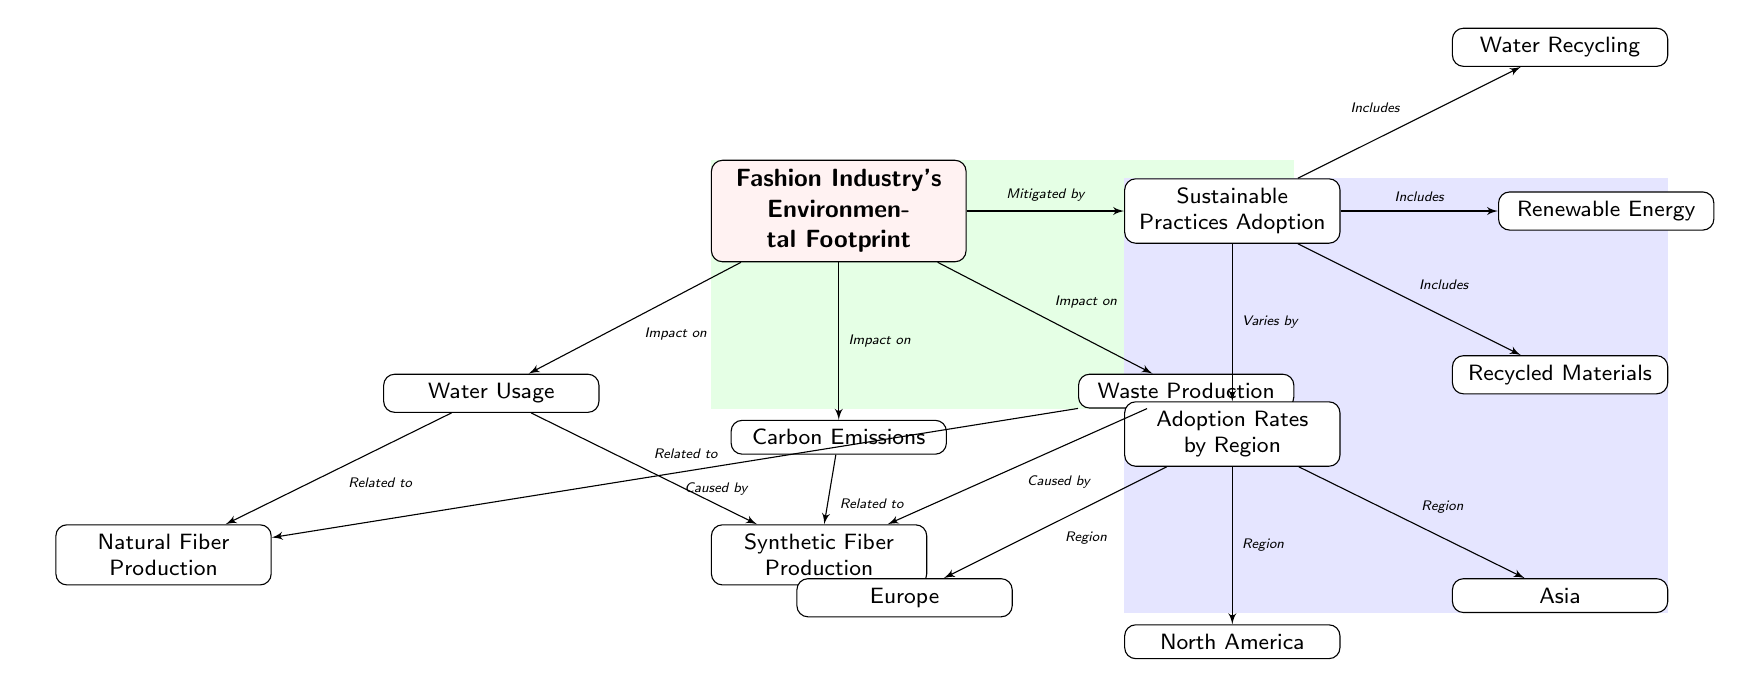What is the main subject of the diagram? The central node labeled "Fashion Industry's Environmental Footprint" indicates that the primary focus of the diagram is to analyze the environmental impact of the fashion industry.
Answer: Fashion Industry's Environmental Footprint How many sustainable practices are mentioned in the diagram? The diagram includes three sustainable practices: Water Recycling, Renewable Energy, and Recycled Materials, which are all listed under the "Sustainable Practices Adoption" node.
Answer: Three What type of relationship connects "Fashion Industry's Environmental Footprint" to "Waste Production"? The connection between these two nodes is labeled "Impact on," showing that the environmental footprint of the fashion industry impacts waste production.
Answer: Impact on Which region is listed as a category for adoption rates? The node directly under "Adoption Rates by Region" is labeled "Europe," indicating that it is one of the regions analyzed for sustainable practice adoption rates.
Answer: Europe What does the edge between "Synthetic Fiber Production" and "Carbon Emissions" imply? The edge labeled "Related to" indicates that there is a relationship where synthetic fiber production contributes or correlates to carbon emissions in the fashion industry.
Answer: Related to What is the relationship between "Water Usage" and "Natural Fiber Production"? The relationship is indicated by the edge labeled "Related to," suggesting that water usage is connected to the production of natural fibers.
Answer: Related to How is the adoption of sustainable practices influenced according to the diagram? The diagram states that the adoption of sustainable practices varies by region, as indicated by the "Varies by" label connecting sustainable practices to the "Adoption Rates by Region" node.
Answer: Varies by Which environment impact causes waste production? The diagram specifies that waste production is caused by both synthetic fiber production and natural fiber production, as indicated by the edges labeled "Caused by."
Answer: Caused by In the diagram, what does the green background represent? The green background surrounding the main environmental footprint node symbolizes the overarching theme of the environmental aspect of the fashion industry.
Answer: Environmental aspect 